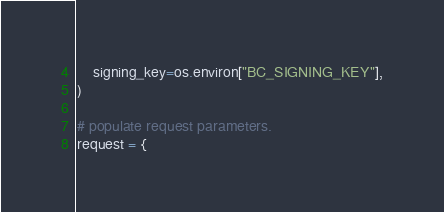<code> <loc_0><loc_0><loc_500><loc_500><_Python_>    signing_key=os.environ["BC_SIGNING_KEY"],
)

# populate request parameters.
request = {</code> 